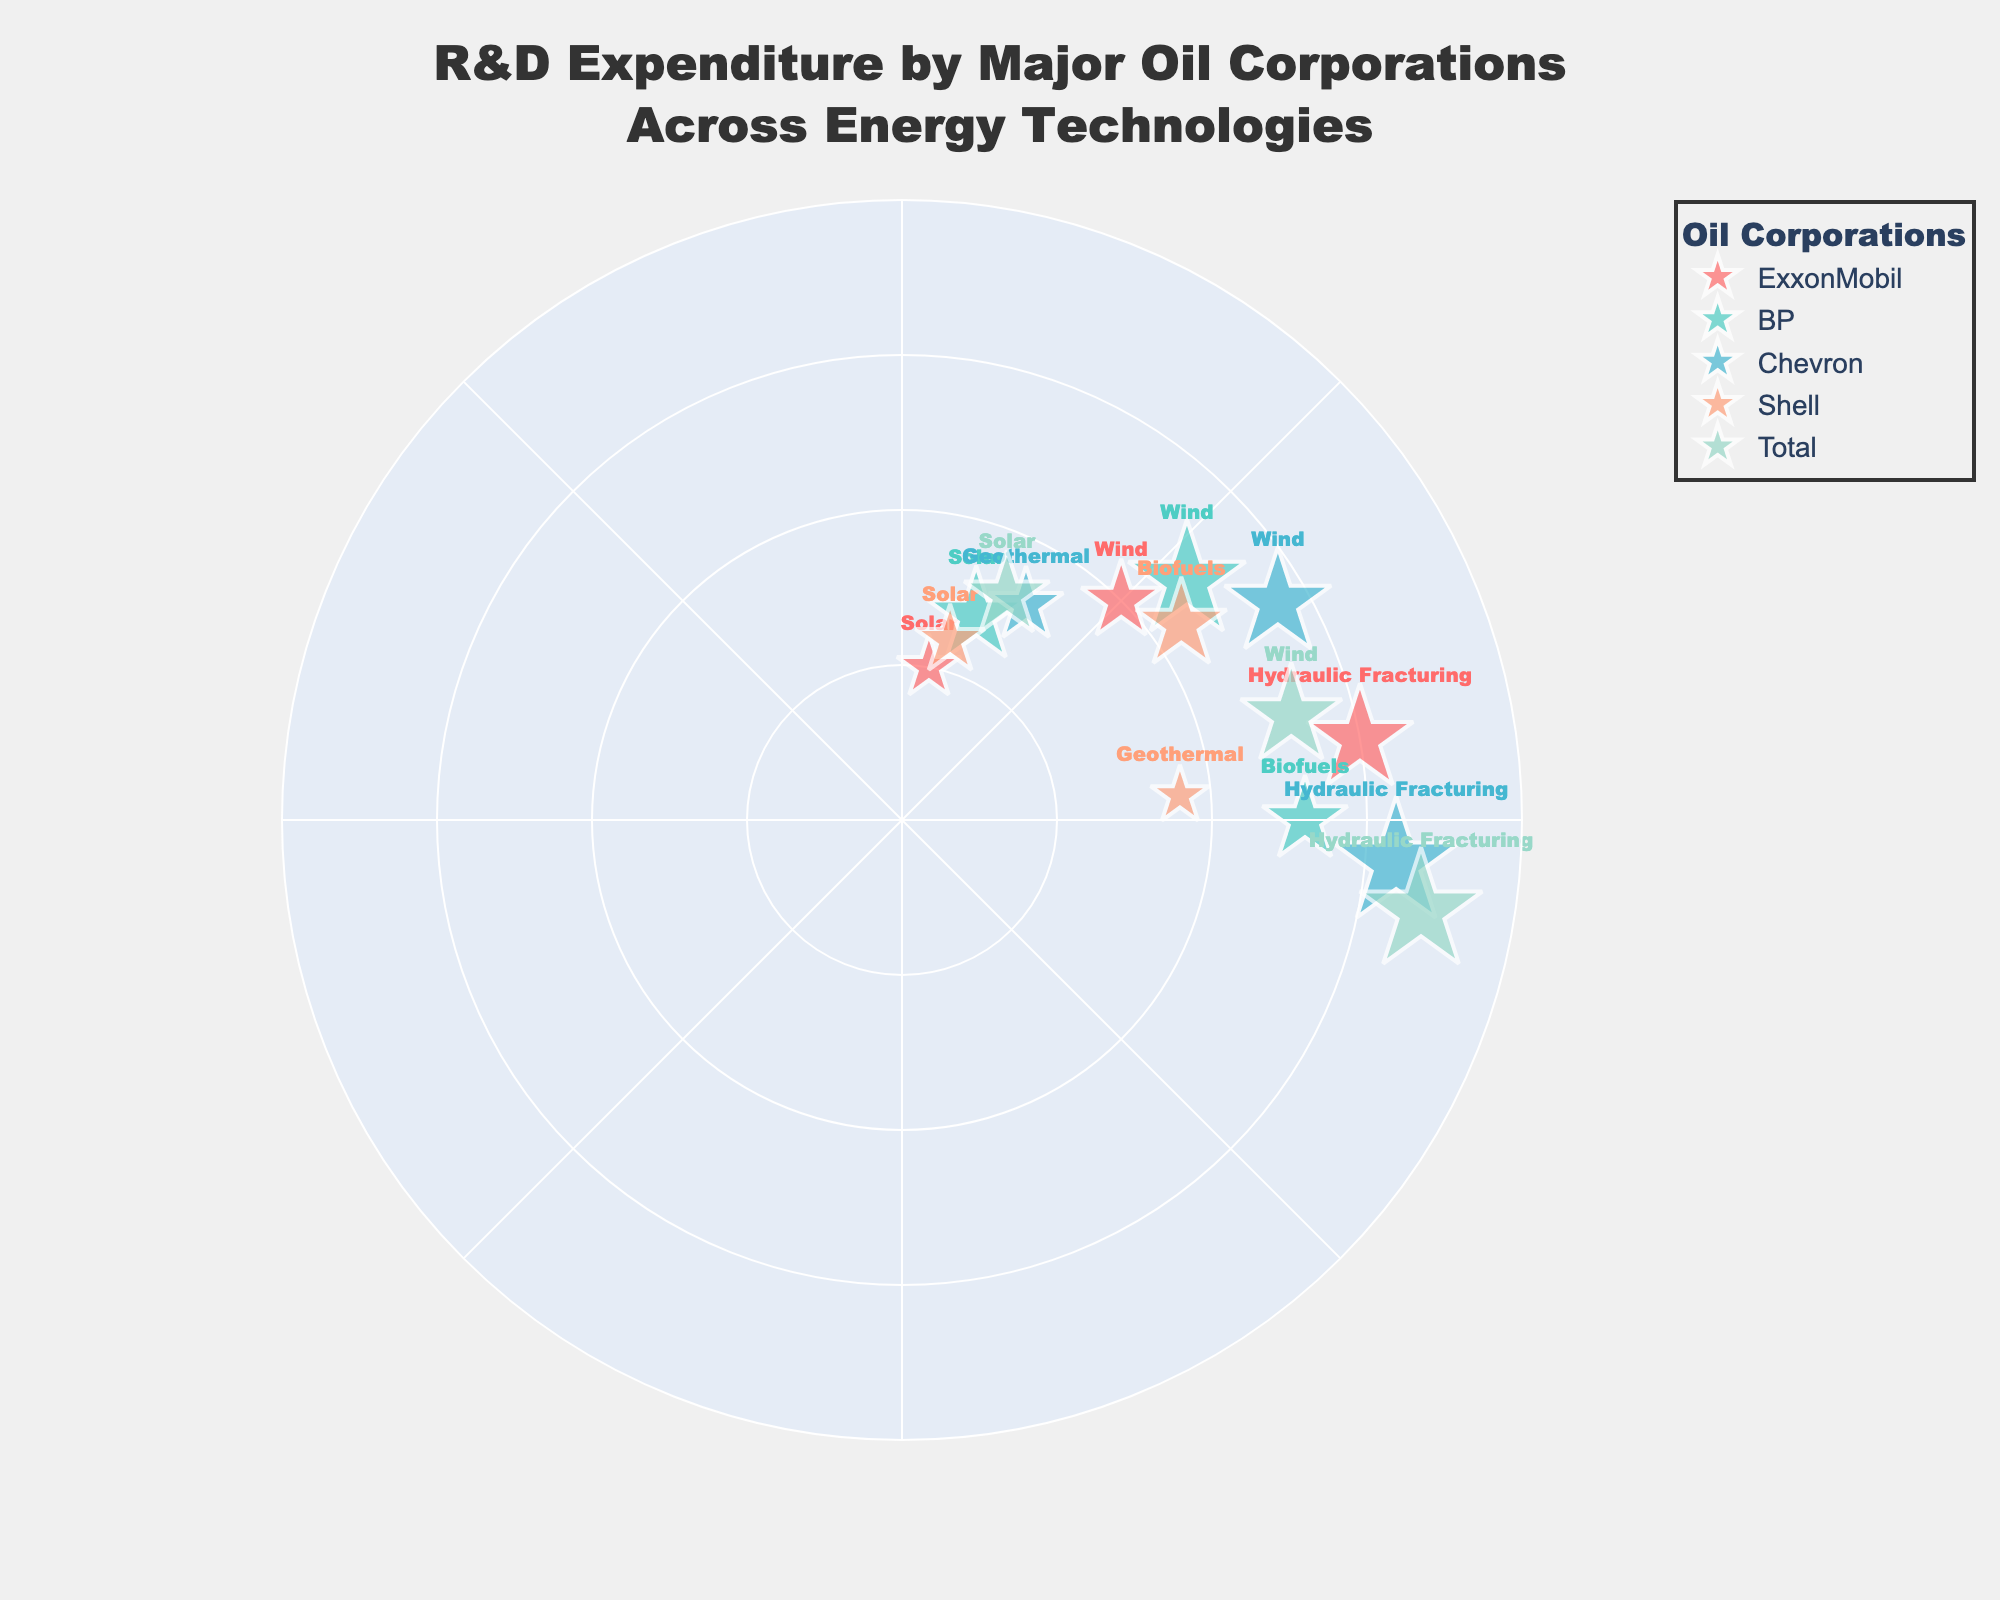What's the title of the figure? The title is usually located at the top of the figure. For this figure, it reads “R&D Expenditure by Major Oil Corporations Across Energy Technologies.”
Answer: R&D Expenditure by Major Oil Corporations Across Energy Technologies Which company has the highest expenditure in Hydraulic Fracturing? Look at the radial distances (expenditure levels) and associated labels for Hydraulic Fracturing. Chevron has the highest expenditure of $240M.
Answer: Chevron What is the total R&D expenditure on Wind energy by all companies? Sum the expenditures for Wind energy across all four companies: ExxonMobil ($150M), BP ($220M), Chevron ($200M), and Total ($190M). 150 + 220 + 200 + 190 = 760M
Answer: $760M Which company spent the most on Solar energy R&D? Compare the radial distances associated with Solar energy for each company. ExxonMobil spent $120M, BP $180M, Shell $130M, and Total $160M. BP has the highest expenditure.
Answer: BP How many different energy technologies are represented in the figure? The unique energy technologies shown in the figure are Solar, Wind, Hydraulic Fracturing, Biofuels, and Geothermal. Count them: 5 technologies.
Answer: 5 Which energy technology did Shell spend $11M on? Look at the expenditure labels for Shell and find the one with $11M. It is Biofuels.
Answer: Biofuels Compare the R&D expenditure on Wind by Chevron and ExxonMobil. Which is higher? Compare the radial distances for Wind technology marked for Chevron and ExxonMobil. Chevron has $200M expenditure, and ExxonMobil has $150M expenditure. Chevron’s expenditure is higher.
Answer: Chevron What is the average expenditure by ExxonMobil on all energy technologies shown? ExxonMobil's expenditure numbers are Solar ($120M), Wind ($150M), and Hydraulic Fracturing ($200M). The average is calculated as (120 + 150 + 200) / 3 = 156.67M
Answer: $156.67M What colors represent the companies in the figure? Identify the colors used in the figure for each company. ExxonMobil is represented by #FF6B6B, BP by #4ECDC4, Chevron by #45B7D1, Shell by #FFA07A, and Total by #98D8C8.
Answer: Five different colors (distinct for each company) Which company’s data point has the largest marker? The size of the marker is proportional to the expenditure divided by 5. Total's expenditure in Hydraulic Fracturing is $230M, which is the highest and thus has the largest marker.
Answer: Total 